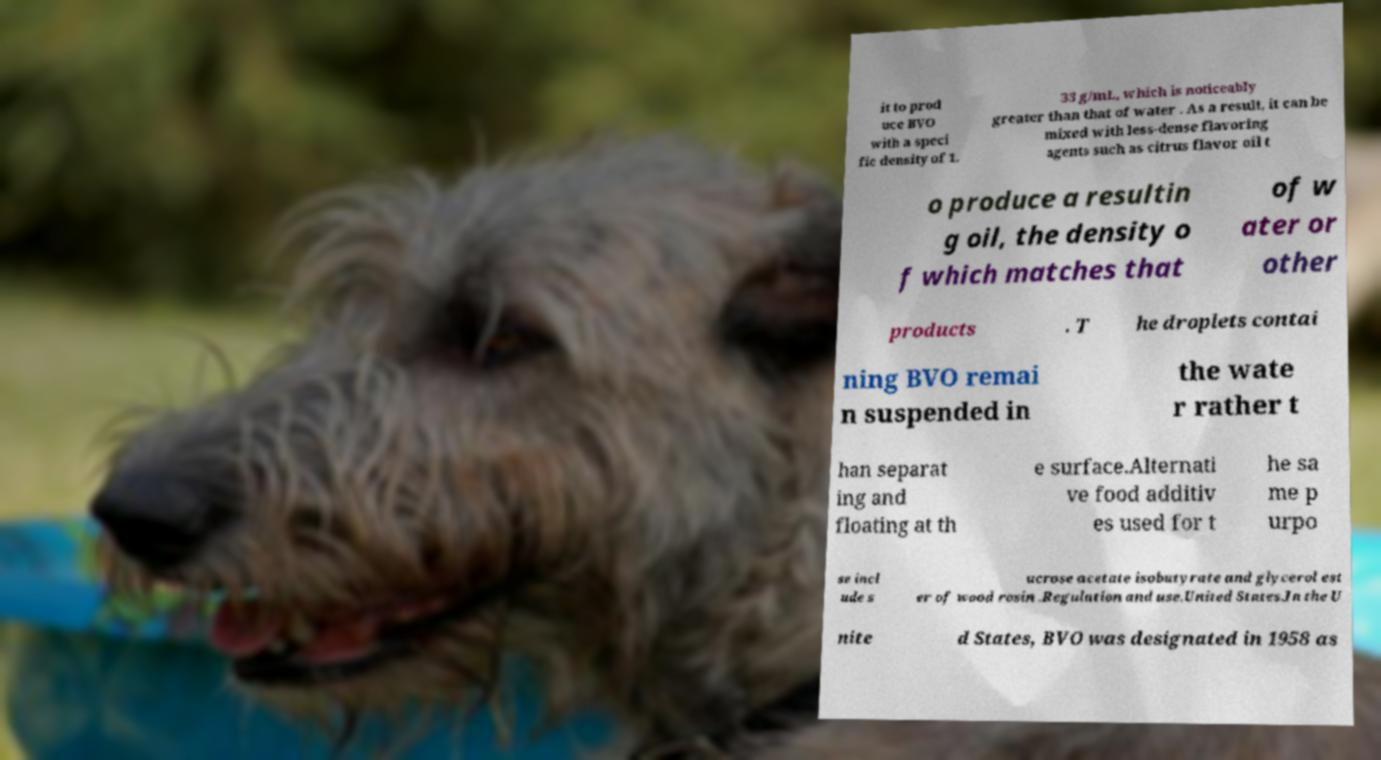Please read and relay the text visible in this image. What does it say? it to prod uce BVO with a speci fic density of 1. 33 g/mL, which is noticeably greater than that of water . As a result, it can be mixed with less-dense flavoring agents such as citrus flavor oil t o produce a resultin g oil, the density o f which matches that of w ater or other products . T he droplets contai ning BVO remai n suspended in the wate r rather t han separat ing and floating at th e surface.Alternati ve food additiv es used for t he sa me p urpo se incl ude s ucrose acetate isobutyrate and glycerol est er of wood rosin .Regulation and use.United States.In the U nite d States, BVO was designated in 1958 as 